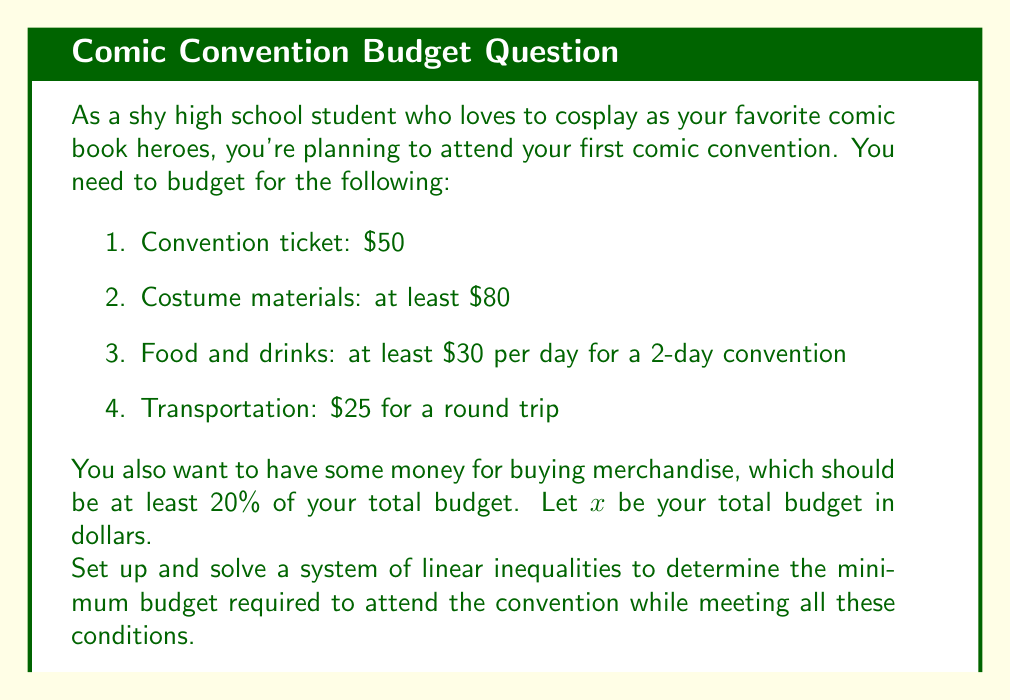Show me your answer to this math problem. Let's break this down step-by-step:

1) First, let's set up the inequalities:

   - Ticket: $50
   - Costume: $x_1 \geq 80$
   - Food and drinks: $x_2 \geq 60$ (for 2 days)
   - Transportation: $25
   - Merchandise: $x_3 \geq 0.2x$ (20% of total budget)

2) The total budget $x$ must be greater than or equal to the sum of all these expenses:

   $$x \geq 50 + x_1 + x_2 + 25 + x_3$$

3) Substituting the known values and inequalities:

   $$x \geq 50 + 80 + 60 + 25 + 0.2x$$

4) Simplify:

   $$x \geq 215 + 0.2x$$

5) Subtract $0.2x$ from both sides:

   $$0.8x \geq 215$$

6) Divide both sides by 0.8:

   $$x \geq 268.75$$

7) Since we're dealing with currency, we need to round up to the nearest dollar:

   $$x \geq 269$$

Therefore, the minimum budget required is $269.
Answer: $269 